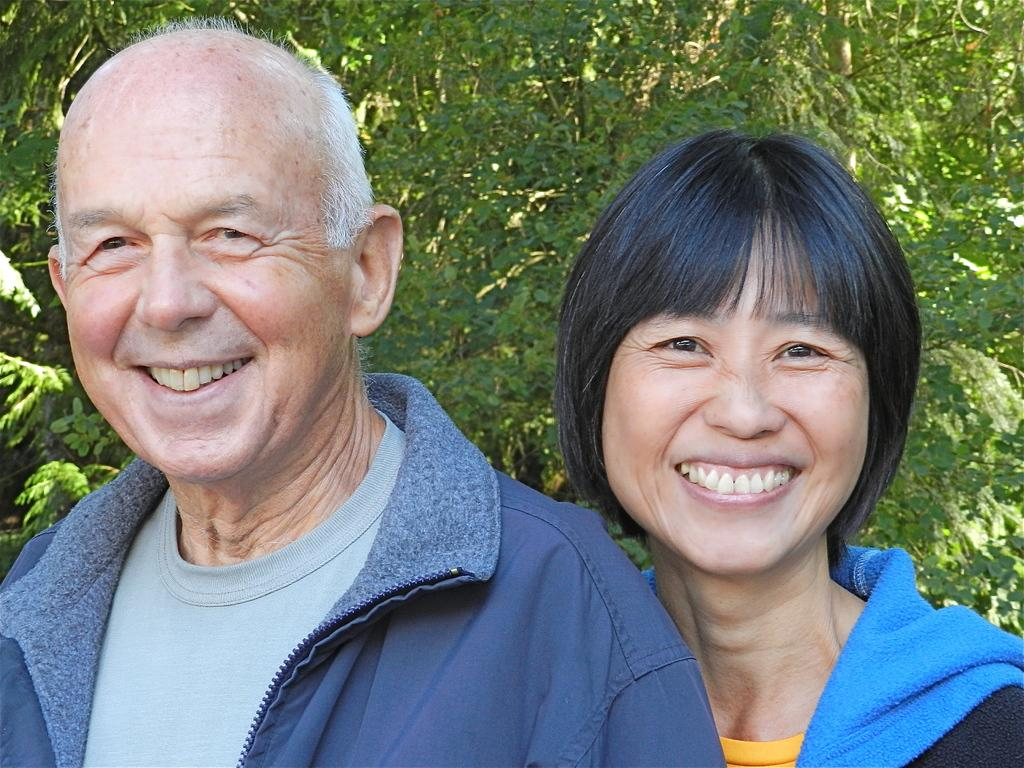How many people are present in the image? There are two people, a man and a woman, present in the image. What are the man and woman doing in the image? The man and woman are standing in the image. What can be seen in the background of the image? There are trees in the background of the image. What type of drum is the man playing in the image? There is no drum present in the image; the man and woman are simply standing. 